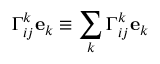Convert formula to latex. <formula><loc_0><loc_0><loc_500><loc_500>\Gamma _ { i j } ^ { k } e _ { k } \equiv \sum _ { k } \Gamma _ { i j } ^ { k } e _ { k }</formula> 